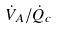Convert formula to latex. <formula><loc_0><loc_0><loc_500><loc_500>\dot { V } _ { A } / \dot { Q } _ { c }</formula> 